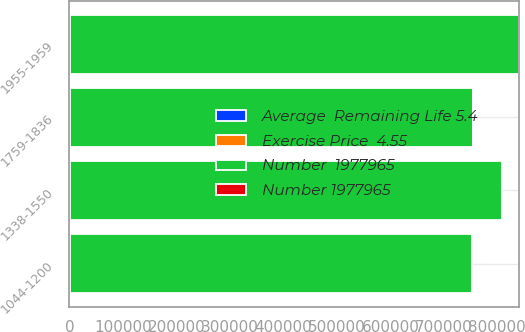Convert chart to OTSL. <chart><loc_0><loc_0><loc_500><loc_500><stacked_bar_chart><ecel><fcel>1044-1200<fcel>1338-1550<fcel>1955-1959<fcel>1759-1836<nl><fcel>Number  1977965<fcel>750872<fcel>806586<fcel>839275<fcel>751850<nl><fcel>Average  Remaining Life 5.4<fcel>2000<fcel>2001<fcel>2002<fcel>2003<nl><fcel>Number 1977965<fcel>6.4<fcel>7.5<fcel>8.4<fcel>9.5<nl><fcel>Exercise Price  4.55<fcel>11.93<fcel>15.46<fcel>19.55<fcel>18.34<nl></chart> 